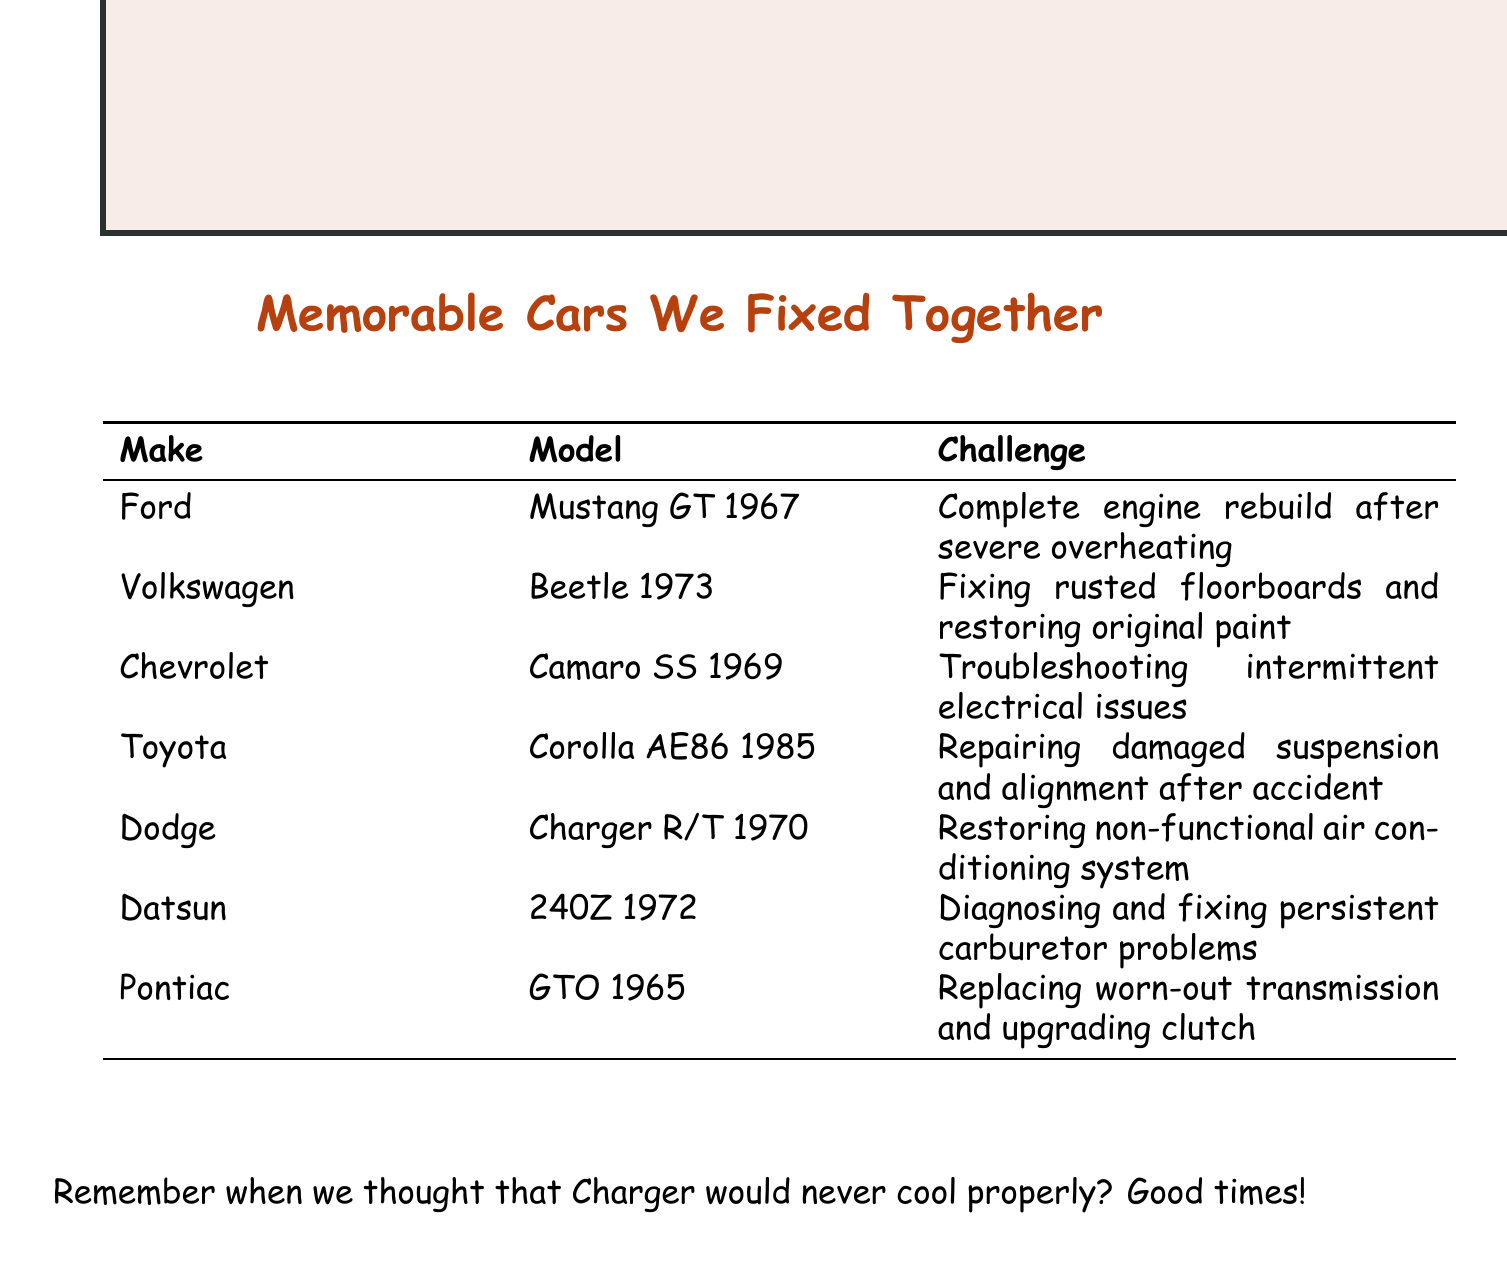What make and model had an engine rebuild? The Ford Mustang GT 1967 had a complete engine rebuild after severe overheating.
Answer: Ford Mustang GT 1967 Which car required fixing rusted floorboards? The Volkswagen Beetle 1973 needed fixing rusted floorboards and restoring original paint.
Answer: Volkswagen Beetle 1973 How many cars in the list are from the year 1970? The document lists two cars from 1970: the Dodge Charger R/T and the Ford Mustang GT.
Answer: 2 What was the unique challenge for the Chevrolet Camaro SS? The Chevrolet Camaro SS 1969 faced troubleshooting intermittent electrical issues.
Answer: Troubleshooting intermittent electrical issues Which car did we work on from Datsun? We worked on the Datsun 240Z 1972.
Answer: Datsun 240Z 1972 What did we upgrade in the Pontiac GTO? In the Pontiac GTO 1965, we upgraded the clutch while replacing the worn-out transmission.
Answer: Upgrading clutch Which car had issues with the air conditioning system? The Dodge Charger R/T 1970 had a non-functional air conditioning system that we restored.
Answer: Dodge Charger R/T 1970 What type of document is this? This document is a list of memorable cars we fixed together, detailing make, model, and challenges.
Answer: Notes 